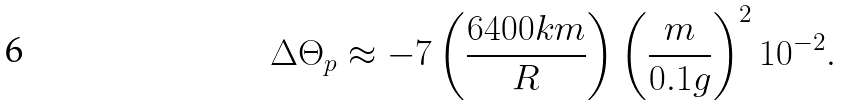Convert formula to latex. <formula><loc_0><loc_0><loc_500><loc_500>\Delta \Theta _ { p } \approx - 7 \left ( \frac { 6 4 0 0 k m } { R } \right ) \left ( \frac { m } { 0 . 1 g } \right ) ^ { 2 } 1 0 ^ { - 2 } .</formula> 